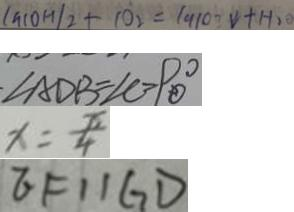Convert formula to latex. <formula><loc_0><loc_0><loc_500><loc_500>( a ( O H ) _ { 2 } + 1 0 _ { 2 } = 1 9 1 0 ^ { \circ } \downarrow + H _ { 2 } O 
 \cdot \angle A D B = \angle C = 9 0 ^ { \circ } 
 x = \frac { \pi } { 4 } 
 E F / / G D</formula> 